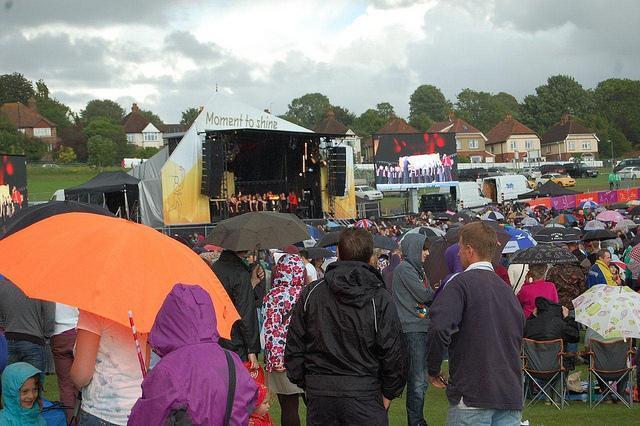How many umbrellas can you see?
Give a very brief answer. 4. How many people can be seen?
Give a very brief answer. 9. How many chairs can you see?
Give a very brief answer. 2. How many train cars are visible here?
Give a very brief answer. 0. 